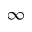Convert formula to latex. <formula><loc_0><loc_0><loc_500><loc_500>\infty</formula> 